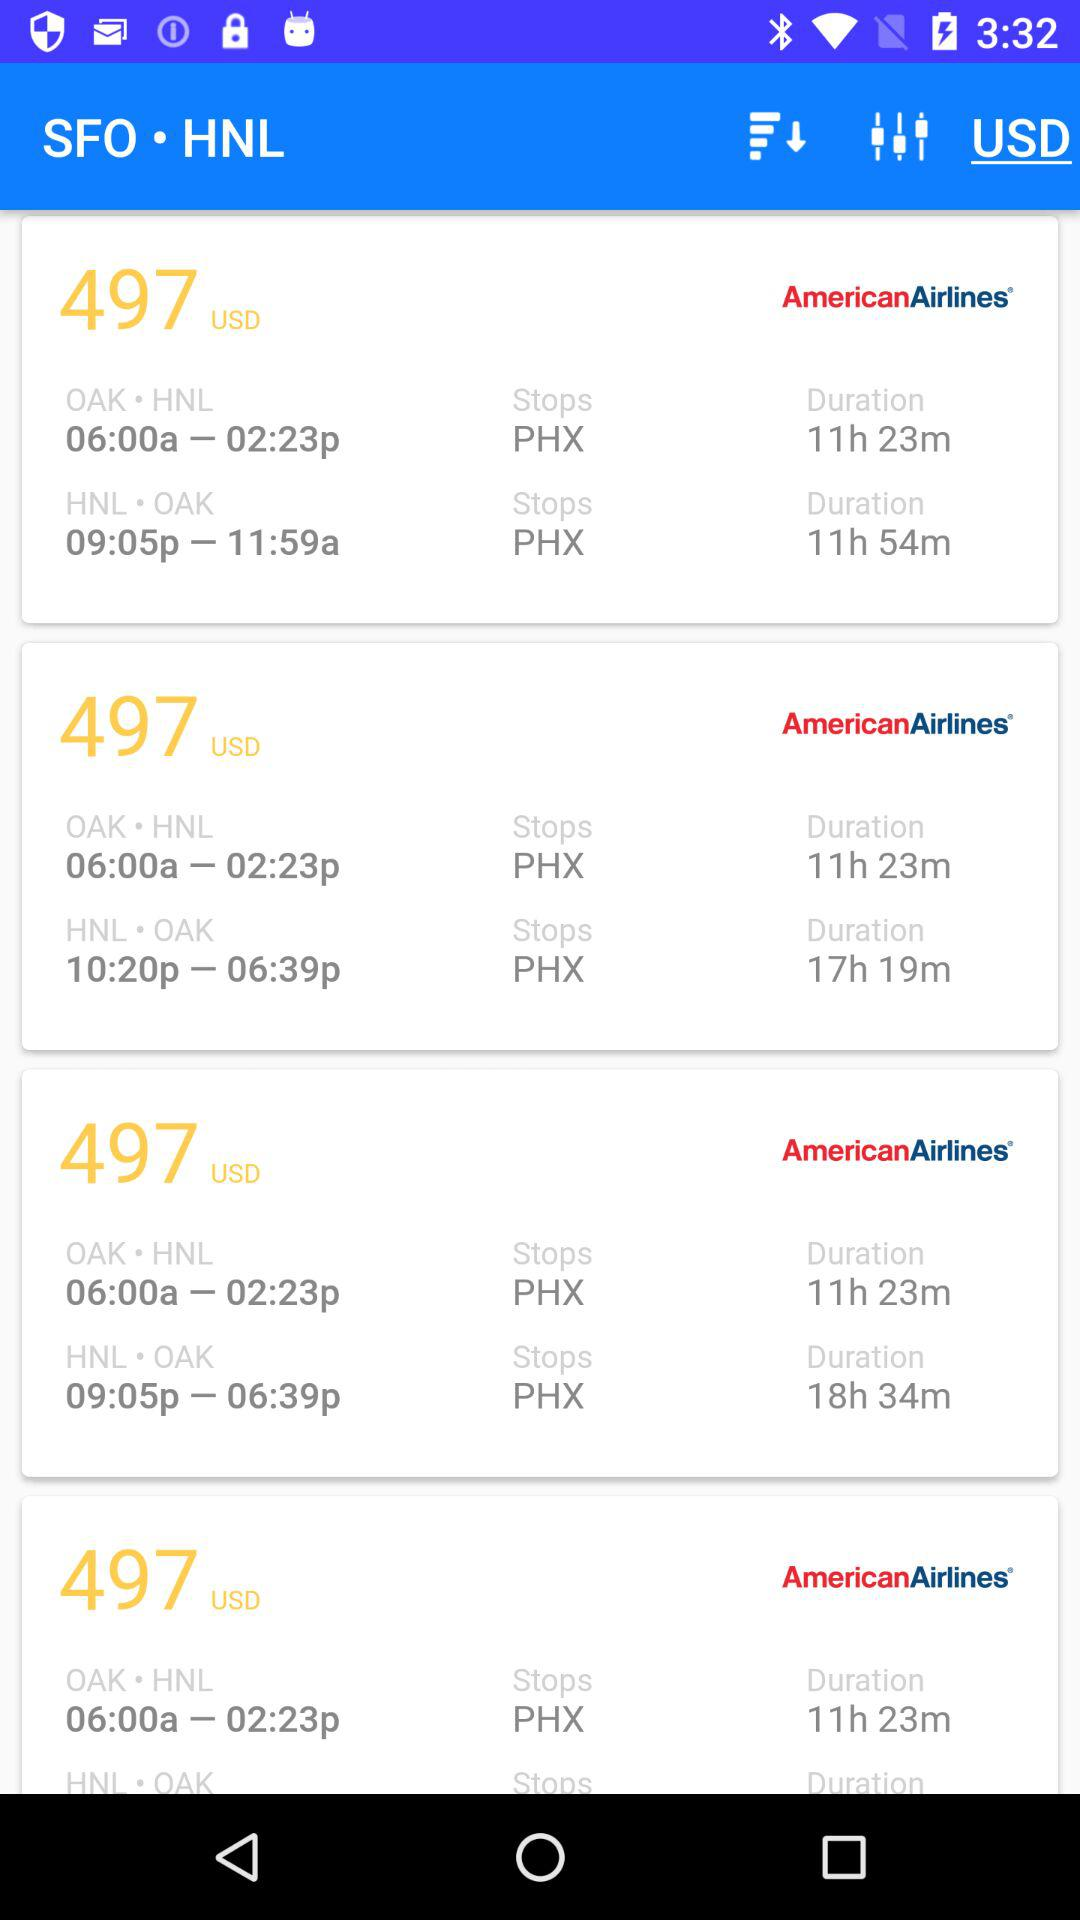What is the price of the American airlines? The price of the American airlines is 497 USD. 